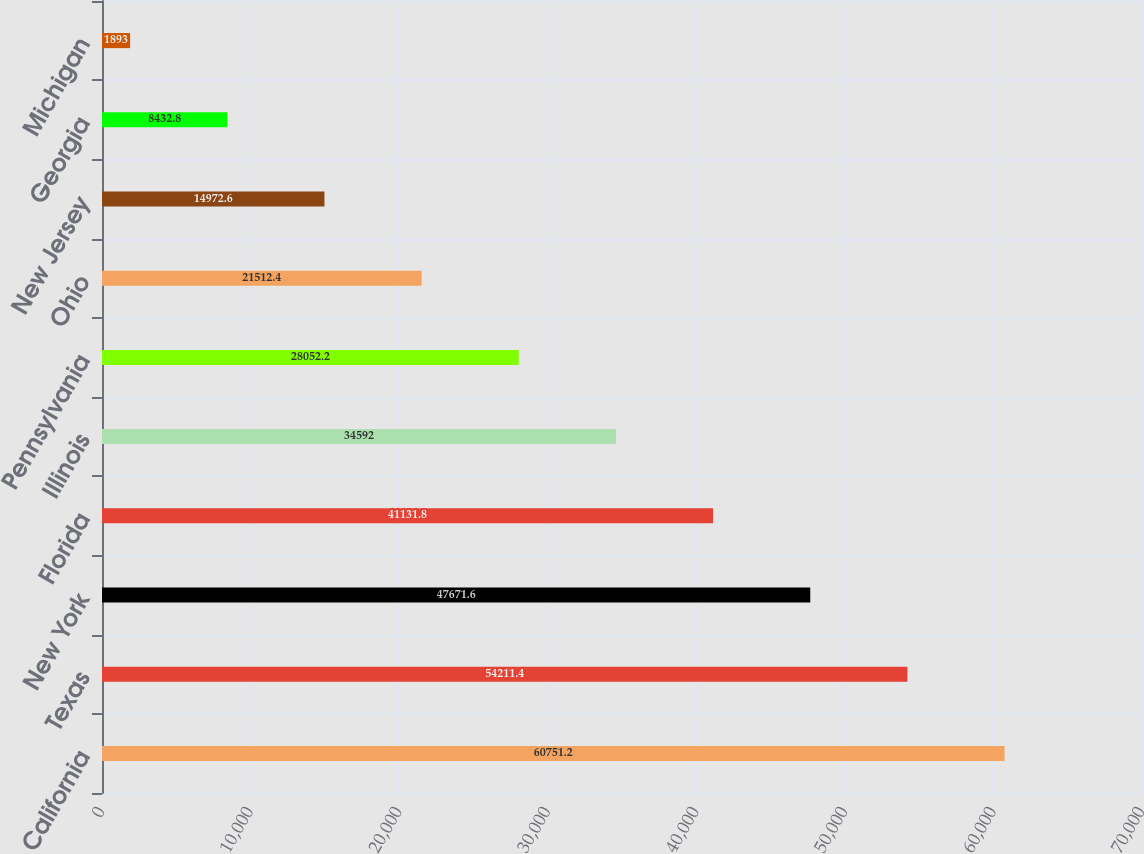Convert chart. <chart><loc_0><loc_0><loc_500><loc_500><bar_chart><fcel>California<fcel>Texas<fcel>New York<fcel>Florida<fcel>Illinois<fcel>Pennsylvania<fcel>Ohio<fcel>New Jersey<fcel>Georgia<fcel>Michigan<nl><fcel>60751.2<fcel>54211.4<fcel>47671.6<fcel>41131.8<fcel>34592<fcel>28052.2<fcel>21512.4<fcel>14972.6<fcel>8432.8<fcel>1893<nl></chart> 